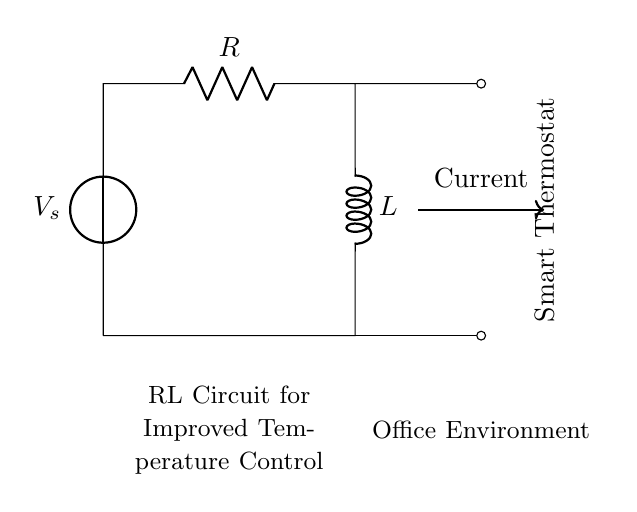What is the voltage source in this circuit? The voltage source is represented by the symbol labeled as \( V_s \) at the top of the circuit, indicating the supply voltage for the RL circuit.
Answer: V_s What components are used in this RL circuit? The circuit contains a resistor, labeled \( R \), and an inductor, labeled \( L \). The resistor limits the current, while the inductor stores energy in a magnetic field.
Answer: Resistor and Inductor What direction does the current flow in this circuit? The current flows in the direction indicated by the arrow labeled "Current" moving from the left to the right, following the path created by the components in the circuit.
Answer: Left to right What is the relationship between the resistor and the inductor in this circuit? The resistor and inductor are connected in series, which means that the same current passes through both components sequentially, influencing the overall impedance and energy storage in the circuit.
Answer: In series What happens to the current when the voltage is applied? When voltage is applied, the inductor initially opposes changes in current due to inductance, causing a gradual increase in current over time rather than an immediate jump to maximum value. This is due to the inductor's property of inductance, which resists changes to current.
Answer: Gradual increase How does this RL circuit improve temperature control in a smart thermostat? The RL circuit can provide a more stable and smooth response to changes in temperature demand by modulating the current flow, which helps to maintain a more constant temperature rather than experiencing sharp fluctuations. The inductor smooths out the changes, making the system more efficient.
Answer: Provides stable response 